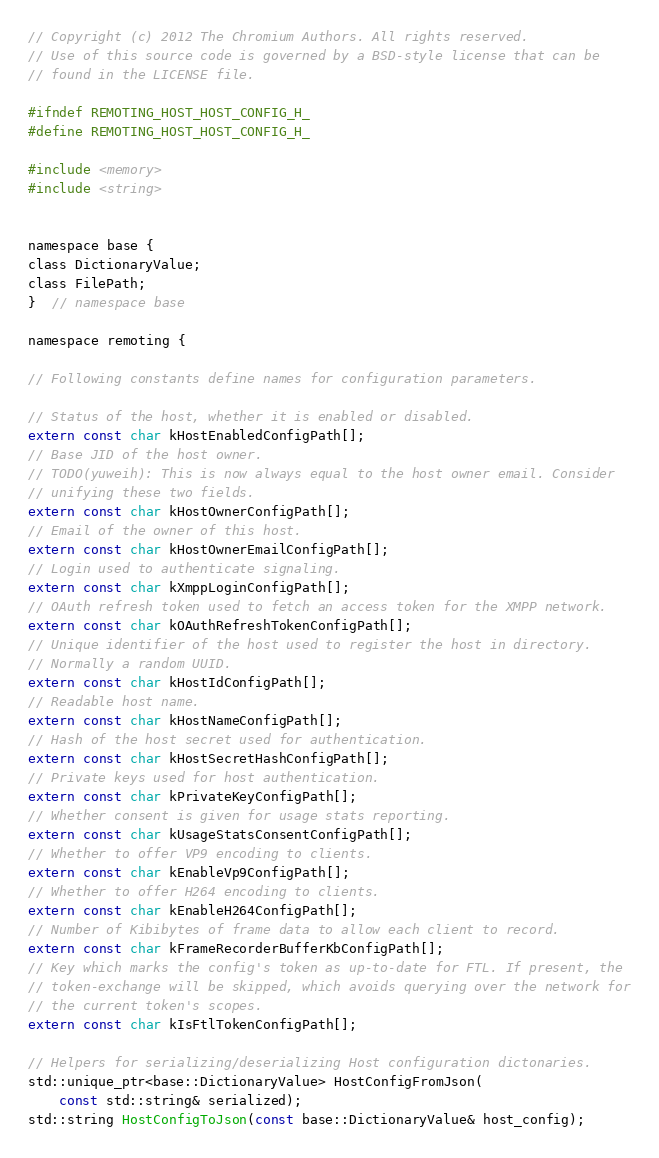Convert code to text. <code><loc_0><loc_0><loc_500><loc_500><_C_>// Copyright (c) 2012 The Chromium Authors. All rights reserved.
// Use of this source code is governed by a BSD-style license that can be
// found in the LICENSE file.

#ifndef REMOTING_HOST_HOST_CONFIG_H_
#define REMOTING_HOST_HOST_CONFIG_H_

#include <memory>
#include <string>


namespace base {
class DictionaryValue;
class FilePath;
}  // namespace base

namespace remoting {

// Following constants define names for configuration parameters.

// Status of the host, whether it is enabled or disabled.
extern const char kHostEnabledConfigPath[];
// Base JID of the host owner.
// TODO(yuweih): This is now always equal to the host owner email. Consider
// unifying these two fields.
extern const char kHostOwnerConfigPath[];
// Email of the owner of this host.
extern const char kHostOwnerEmailConfigPath[];
// Login used to authenticate signaling.
extern const char kXmppLoginConfigPath[];
// OAuth refresh token used to fetch an access token for the XMPP network.
extern const char kOAuthRefreshTokenConfigPath[];
// Unique identifier of the host used to register the host in directory.
// Normally a random UUID.
extern const char kHostIdConfigPath[];
// Readable host name.
extern const char kHostNameConfigPath[];
// Hash of the host secret used for authentication.
extern const char kHostSecretHashConfigPath[];
// Private keys used for host authentication.
extern const char kPrivateKeyConfigPath[];
// Whether consent is given for usage stats reporting.
extern const char kUsageStatsConsentConfigPath[];
// Whether to offer VP9 encoding to clients.
extern const char kEnableVp9ConfigPath[];
// Whether to offer H264 encoding to clients.
extern const char kEnableH264ConfigPath[];
// Number of Kibibytes of frame data to allow each client to record.
extern const char kFrameRecorderBufferKbConfigPath[];
// Key which marks the config's token as up-to-date for FTL. If present, the
// token-exchange will be skipped, which avoids querying over the network for
// the current token's scopes.
extern const char kIsFtlTokenConfigPath[];

// Helpers for serializing/deserializing Host configuration dictonaries.
std::unique_ptr<base::DictionaryValue> HostConfigFromJson(
    const std::string& serialized);
std::string HostConfigToJson(const base::DictionaryValue& host_config);
</code> 